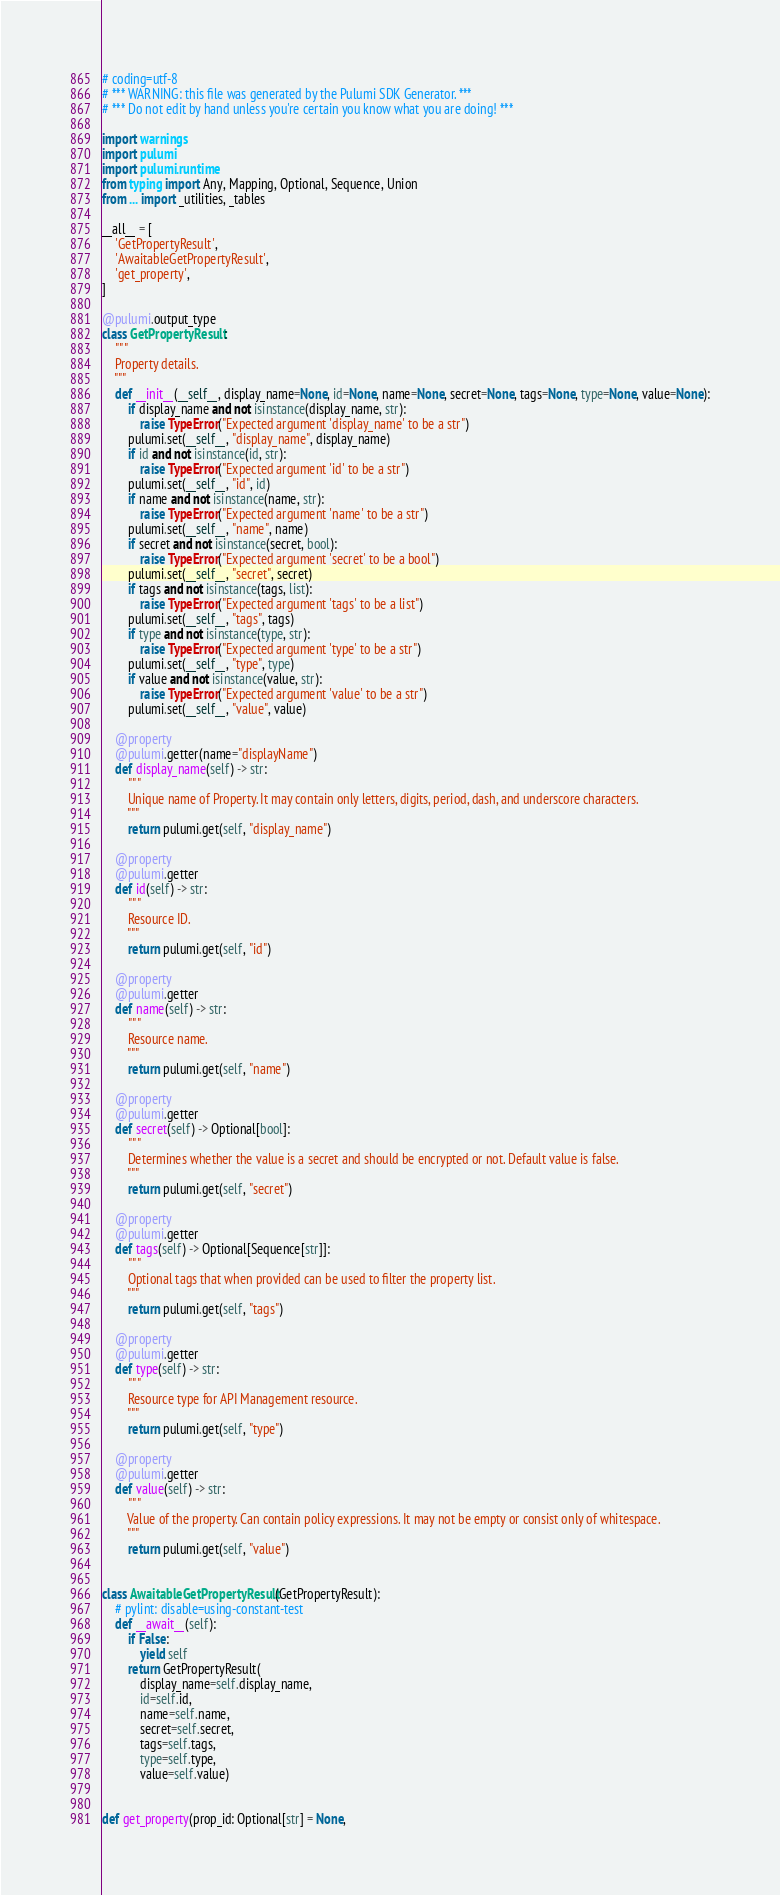<code> <loc_0><loc_0><loc_500><loc_500><_Python_># coding=utf-8
# *** WARNING: this file was generated by the Pulumi SDK Generator. ***
# *** Do not edit by hand unless you're certain you know what you are doing! ***

import warnings
import pulumi
import pulumi.runtime
from typing import Any, Mapping, Optional, Sequence, Union
from ... import _utilities, _tables

__all__ = [
    'GetPropertyResult',
    'AwaitableGetPropertyResult',
    'get_property',
]

@pulumi.output_type
class GetPropertyResult:
    """
    Property details.
    """
    def __init__(__self__, display_name=None, id=None, name=None, secret=None, tags=None, type=None, value=None):
        if display_name and not isinstance(display_name, str):
            raise TypeError("Expected argument 'display_name' to be a str")
        pulumi.set(__self__, "display_name", display_name)
        if id and not isinstance(id, str):
            raise TypeError("Expected argument 'id' to be a str")
        pulumi.set(__self__, "id", id)
        if name and not isinstance(name, str):
            raise TypeError("Expected argument 'name' to be a str")
        pulumi.set(__self__, "name", name)
        if secret and not isinstance(secret, bool):
            raise TypeError("Expected argument 'secret' to be a bool")
        pulumi.set(__self__, "secret", secret)
        if tags and not isinstance(tags, list):
            raise TypeError("Expected argument 'tags' to be a list")
        pulumi.set(__self__, "tags", tags)
        if type and not isinstance(type, str):
            raise TypeError("Expected argument 'type' to be a str")
        pulumi.set(__self__, "type", type)
        if value and not isinstance(value, str):
            raise TypeError("Expected argument 'value' to be a str")
        pulumi.set(__self__, "value", value)

    @property
    @pulumi.getter(name="displayName")
    def display_name(self) -> str:
        """
        Unique name of Property. It may contain only letters, digits, period, dash, and underscore characters.
        """
        return pulumi.get(self, "display_name")

    @property
    @pulumi.getter
    def id(self) -> str:
        """
        Resource ID.
        """
        return pulumi.get(self, "id")

    @property
    @pulumi.getter
    def name(self) -> str:
        """
        Resource name.
        """
        return pulumi.get(self, "name")

    @property
    @pulumi.getter
    def secret(self) -> Optional[bool]:
        """
        Determines whether the value is a secret and should be encrypted or not. Default value is false.
        """
        return pulumi.get(self, "secret")

    @property
    @pulumi.getter
    def tags(self) -> Optional[Sequence[str]]:
        """
        Optional tags that when provided can be used to filter the property list.
        """
        return pulumi.get(self, "tags")

    @property
    @pulumi.getter
    def type(self) -> str:
        """
        Resource type for API Management resource.
        """
        return pulumi.get(self, "type")

    @property
    @pulumi.getter
    def value(self) -> str:
        """
        Value of the property. Can contain policy expressions. It may not be empty or consist only of whitespace.
        """
        return pulumi.get(self, "value")


class AwaitableGetPropertyResult(GetPropertyResult):
    # pylint: disable=using-constant-test
    def __await__(self):
        if False:
            yield self
        return GetPropertyResult(
            display_name=self.display_name,
            id=self.id,
            name=self.name,
            secret=self.secret,
            tags=self.tags,
            type=self.type,
            value=self.value)


def get_property(prop_id: Optional[str] = None,</code> 